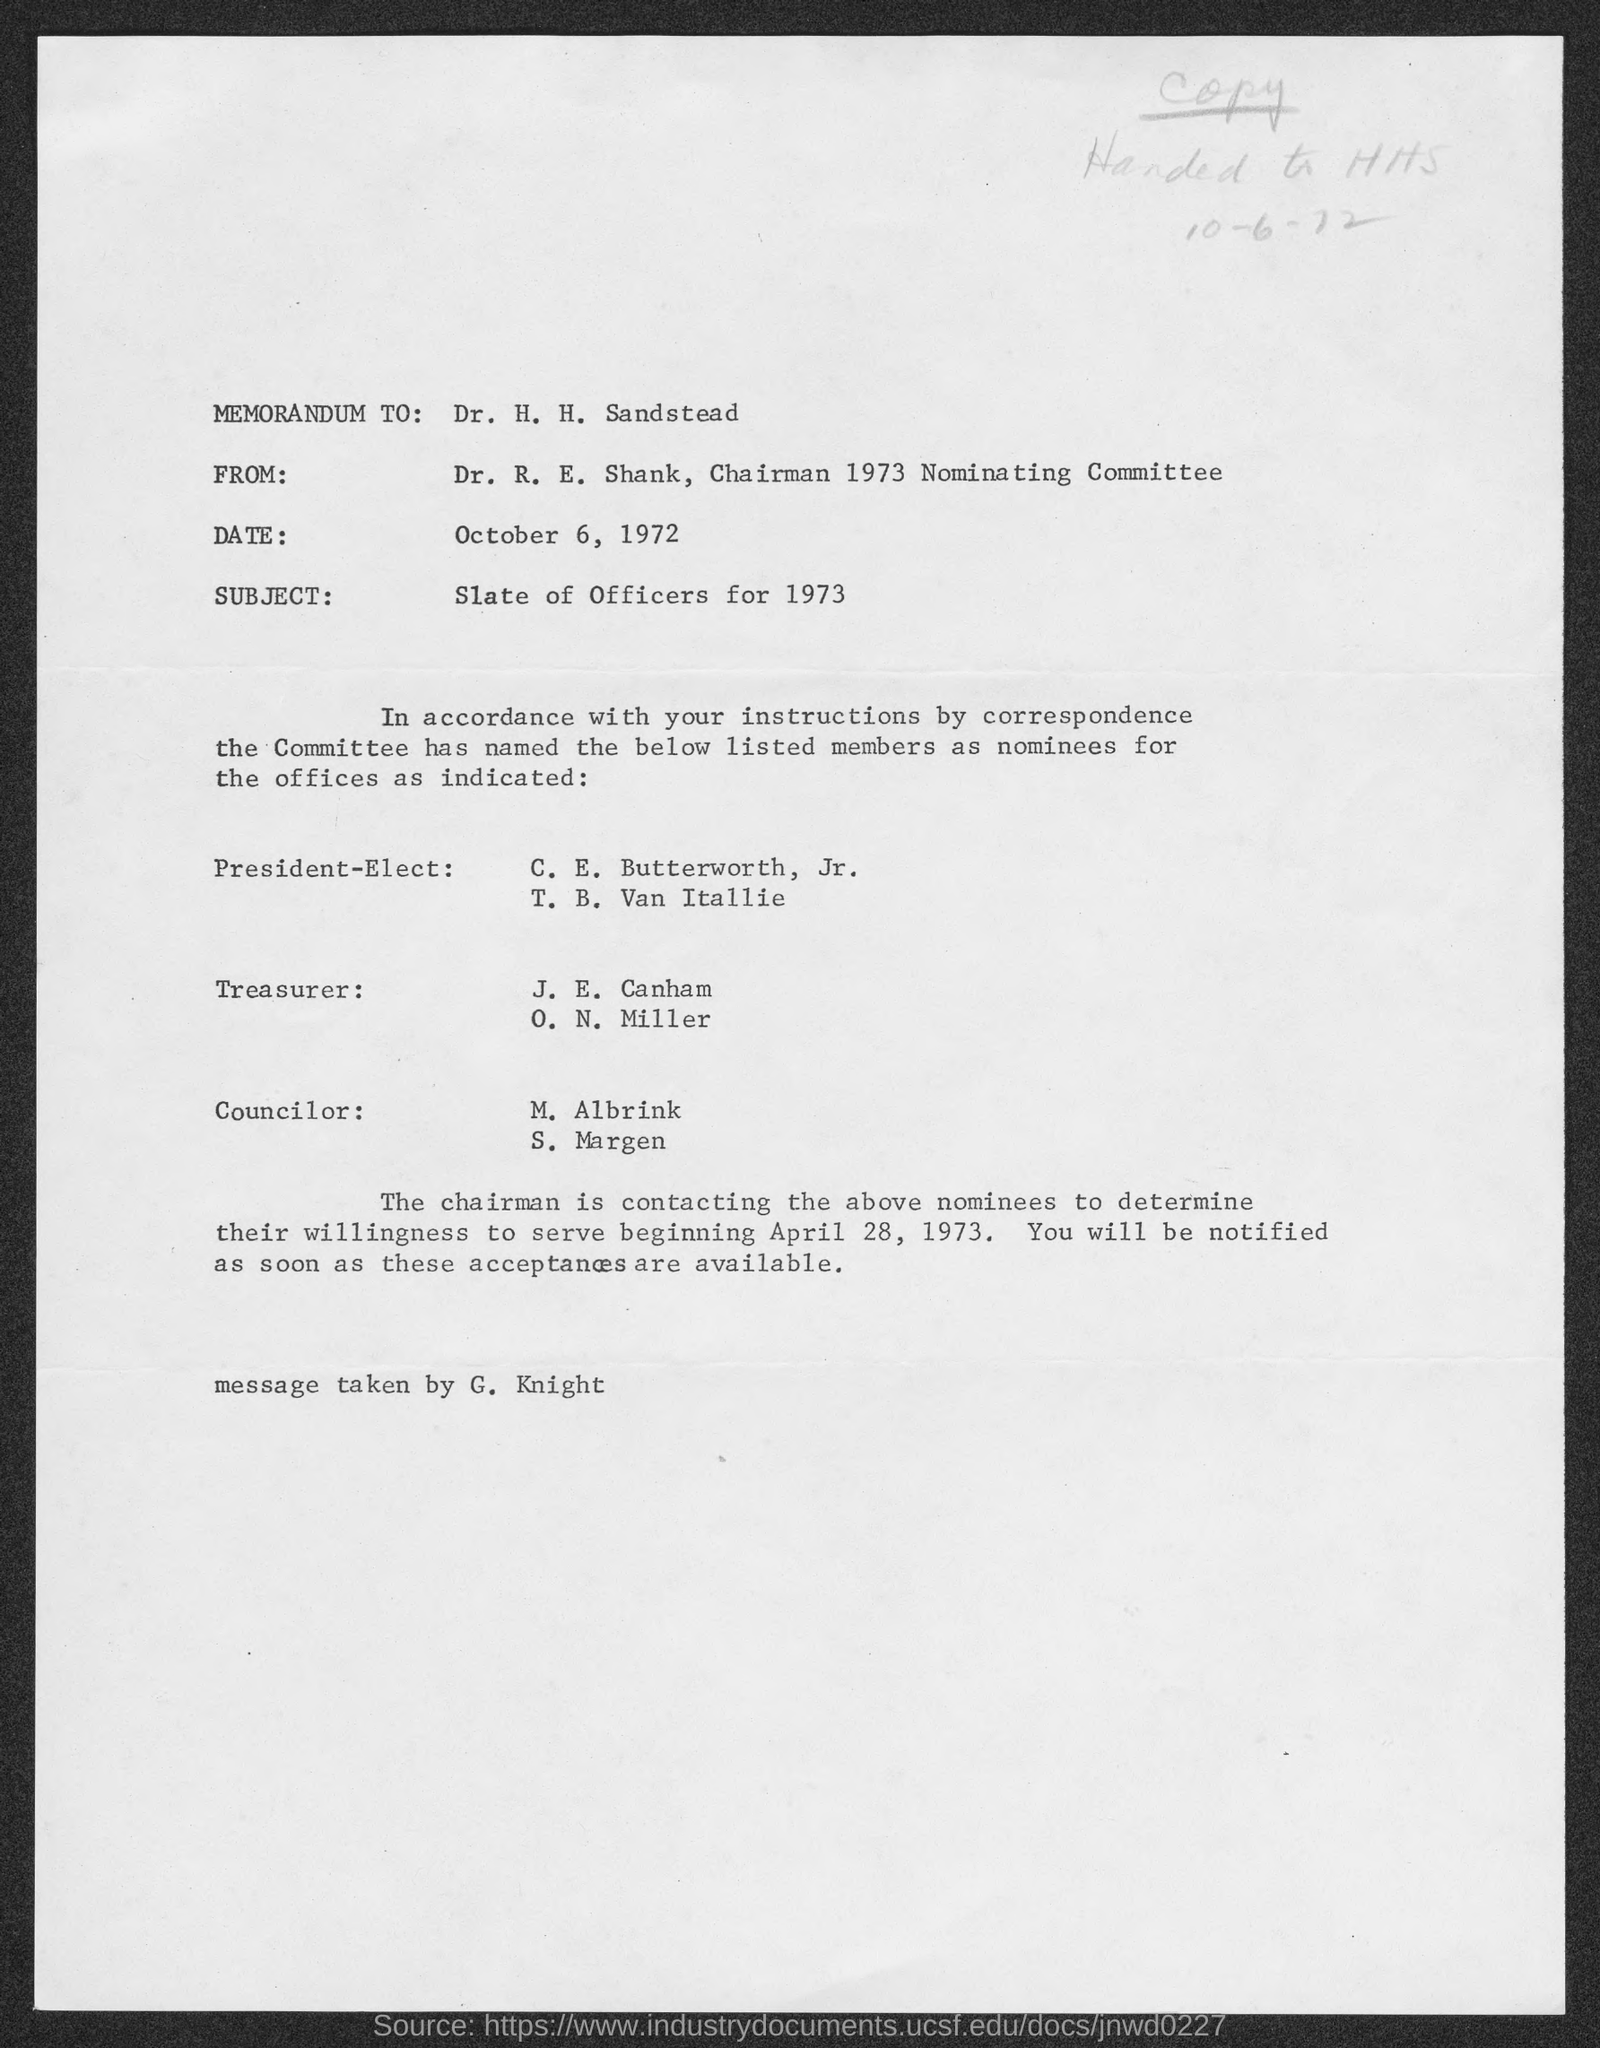What is handwritten date on the document?
Ensure brevity in your answer.  10-6-72. What is the date?
Keep it short and to the point. October 6, 1972. 